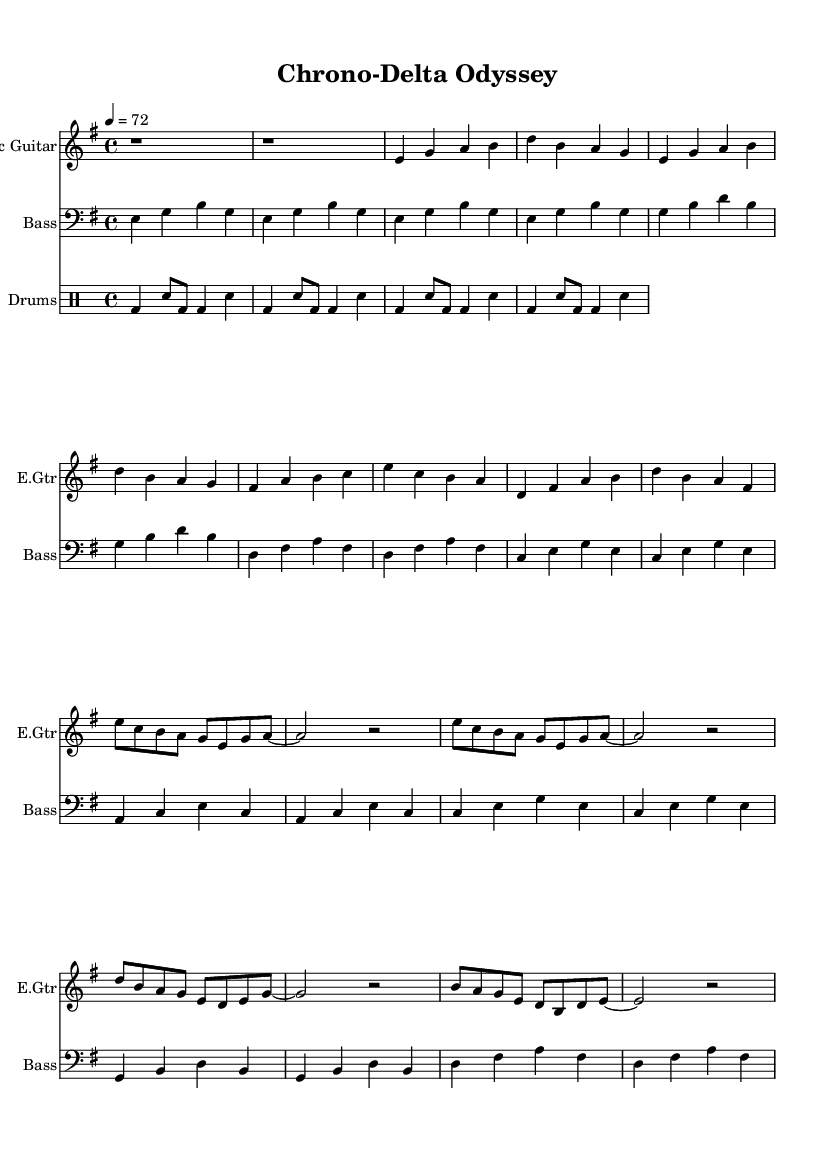What is the key signature of this music? The key signature is indicated by the sharp signs or flat signs at the beginning of the staff. In this case, it shows one sharp, which corresponds to E minor.
Answer: E minor What is the time signature of this music? The time signature is found at the beginning of the staff. Here, it shows a 4 over 4, indicating there are four beats in each measure.
Answer: 4/4 What is the tempo marking of this piece? The tempo marking is specified using a number and a note value at the beginning of the score. This piece is marked at a tempo of 72 beats per minute.
Answer: 72 How many measures are in the chorus section? To find the number of measures in the chorus, we count the bar lines in that section. The chorus consists of four measures as indicated by the bar lines.
Answer: 4 What type of rhythm pattern is used for the drums? The rhythm pattern for the drums can be identified by analyzing how the bass drum and snare are arranged. This music exhibits a basic blues shuffle pattern.
Answer: Shuffle What instruments are included in this score? The instruments are indicated at the beginning of each staff section. The score includes Electric Guitar, Bass, and Drums.
Answer: Electric Guitar, Bass, Drums What is the structure of the song in terms of verses and chorus? The structure can be understood by identifying the different sections marked in the score. It contains an intro, followed by verse 1, and then a chorus, indicating a typical song form.
Answer: Intro, Verse 1, Chorus 